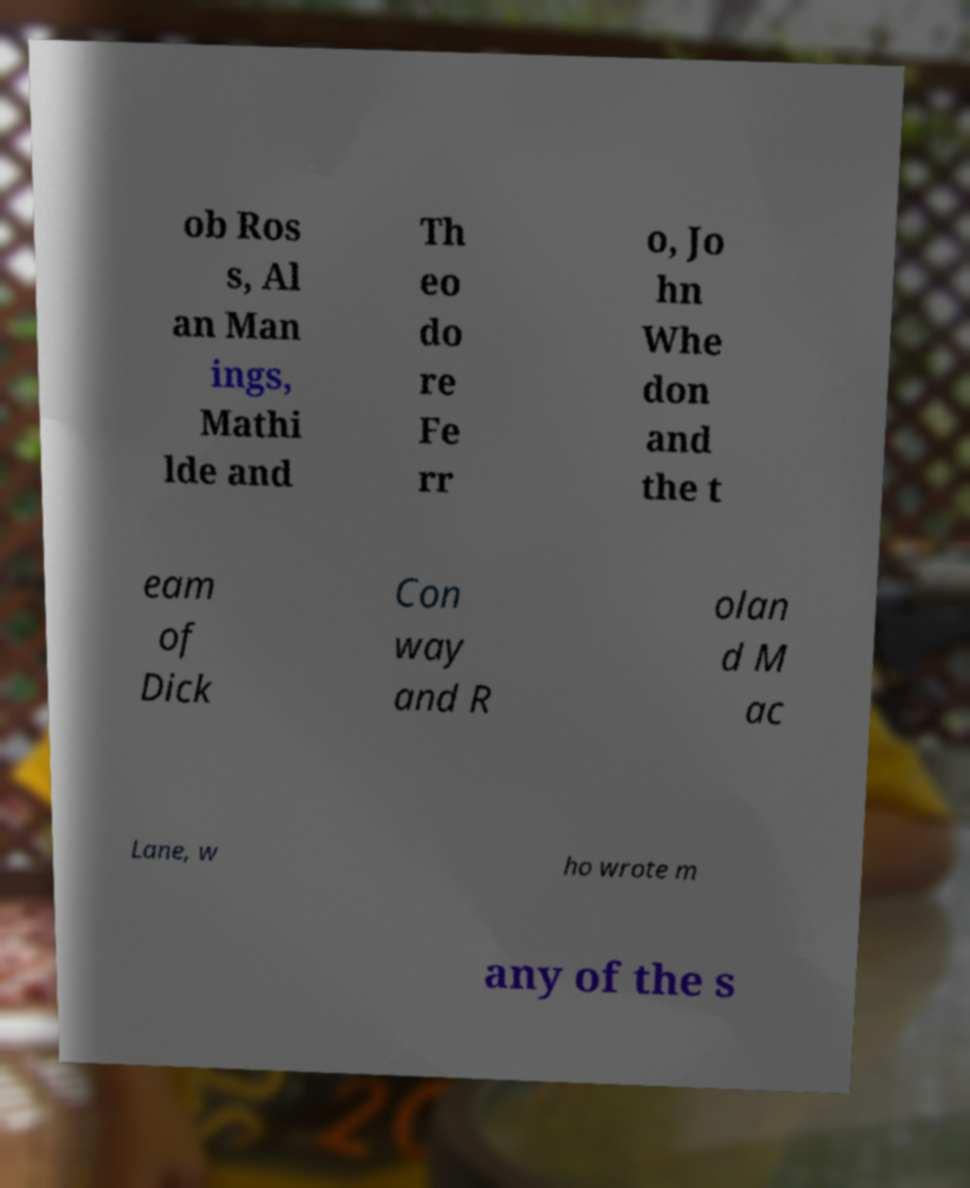For documentation purposes, I need the text within this image transcribed. Could you provide that? ob Ros s, Al an Man ings, Mathi lde and Th eo do re Fe rr o, Jo hn Whe don and the t eam of Dick Con way and R olan d M ac Lane, w ho wrote m any of the s 